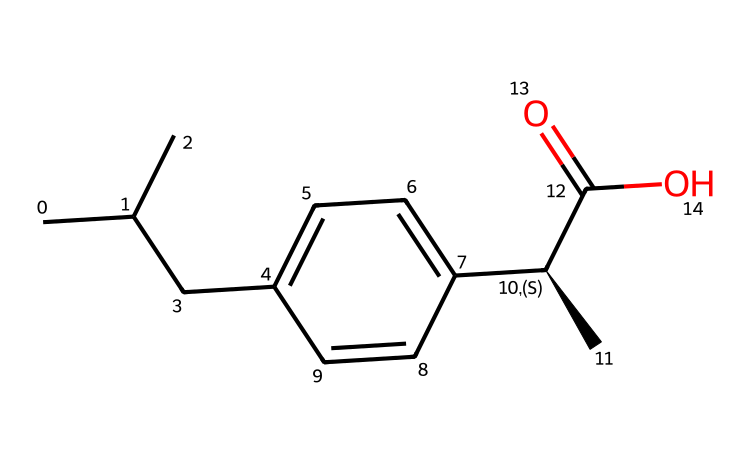What is the molecular formula of ibuprofen? The SMILES notation indicates the presence of carbon (C), hydrogen (H), and oxygen (O) atoms. Counting the carbons, there are 13, for hydrogens, there are 18, and for oxygens, there are 2, resulting in the molecular formula C13H18O2.
Answer: C13H18O2 How many chiral centers are present in ibuprofen? The SMILES representation contains one chiral carbon indicated by the [C@H] notation, which signifies a chiral center where the carbon is attached to four different groups. Therefore, there is one chiral center.
Answer: 1 What functional group characterizes ibuprofen as a carboxylic acid? In the provided SMILES structure, the presence of the -COOH group at the end of the structure indicates the functional group responsible for its classification as a carboxylic acid. This particular group distinguishes it from other types of compounds.
Answer: -COOH How many rings are present in the structure of ibuprofen? The SMILES representation shows only a linear structure with no indication of closed loops or rings, indicating that there are no rings present in the ibuprofen molecule.
Answer: 0 What type of isomerism can ibuprofen exhibit due to its chiral center? The presence of the chiral center allows ibuprofen to exhibit stereoisomerism, specifically enantiomerism, where two molecules can be mirror images of each other. This property is common in compounds that have chiral carbons.
Answer: enantiomerism What is the primary use of ibuprofen in medicine? Ibuprofen is primarily used as a nonsteroidal anti-inflammatory drug (NSAID) that is effective for alleviating pain, reducing inflammation, and lowering fever, making it a commonly used medication in various conditions.
Answer: pain relief 